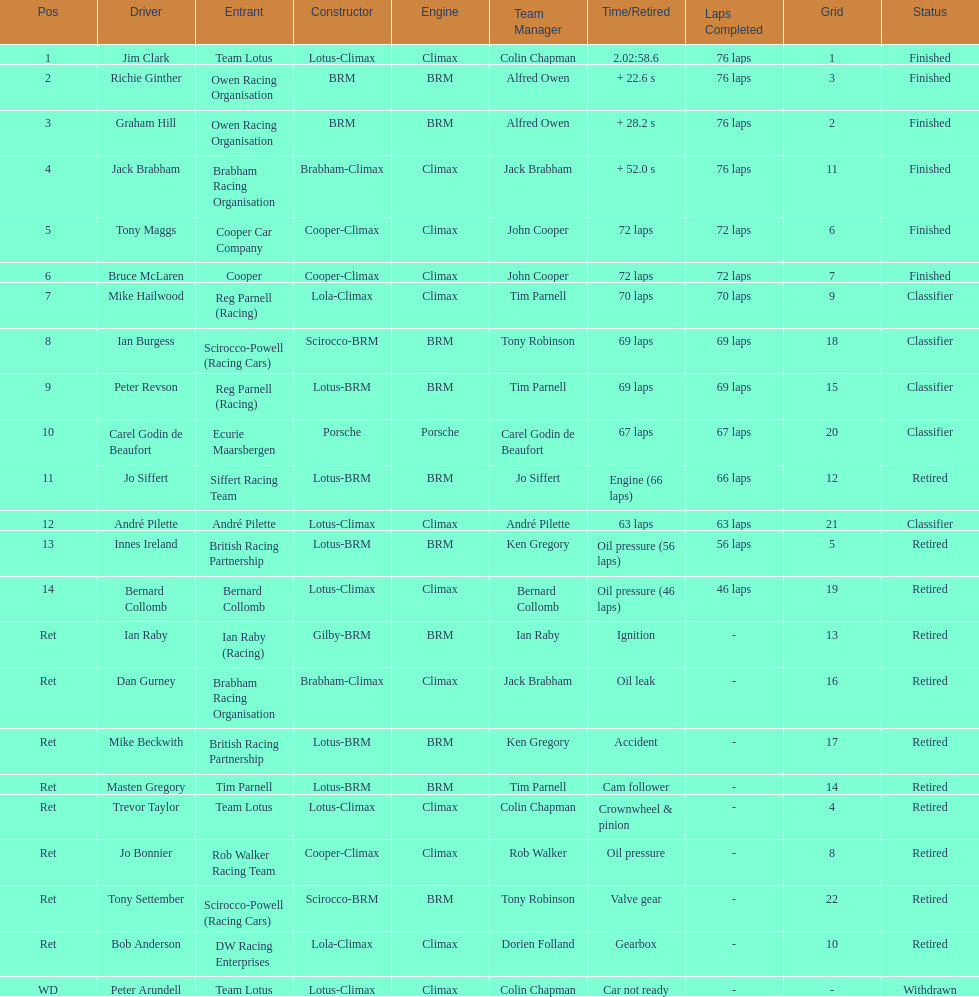Which driver did not have his/her car ready? Peter Arundell. 